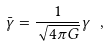<formula> <loc_0><loc_0><loc_500><loc_500>\bar { \gamma } = \frac { 1 } { \sqrt { 4 \pi G } } \gamma \ ,</formula> 